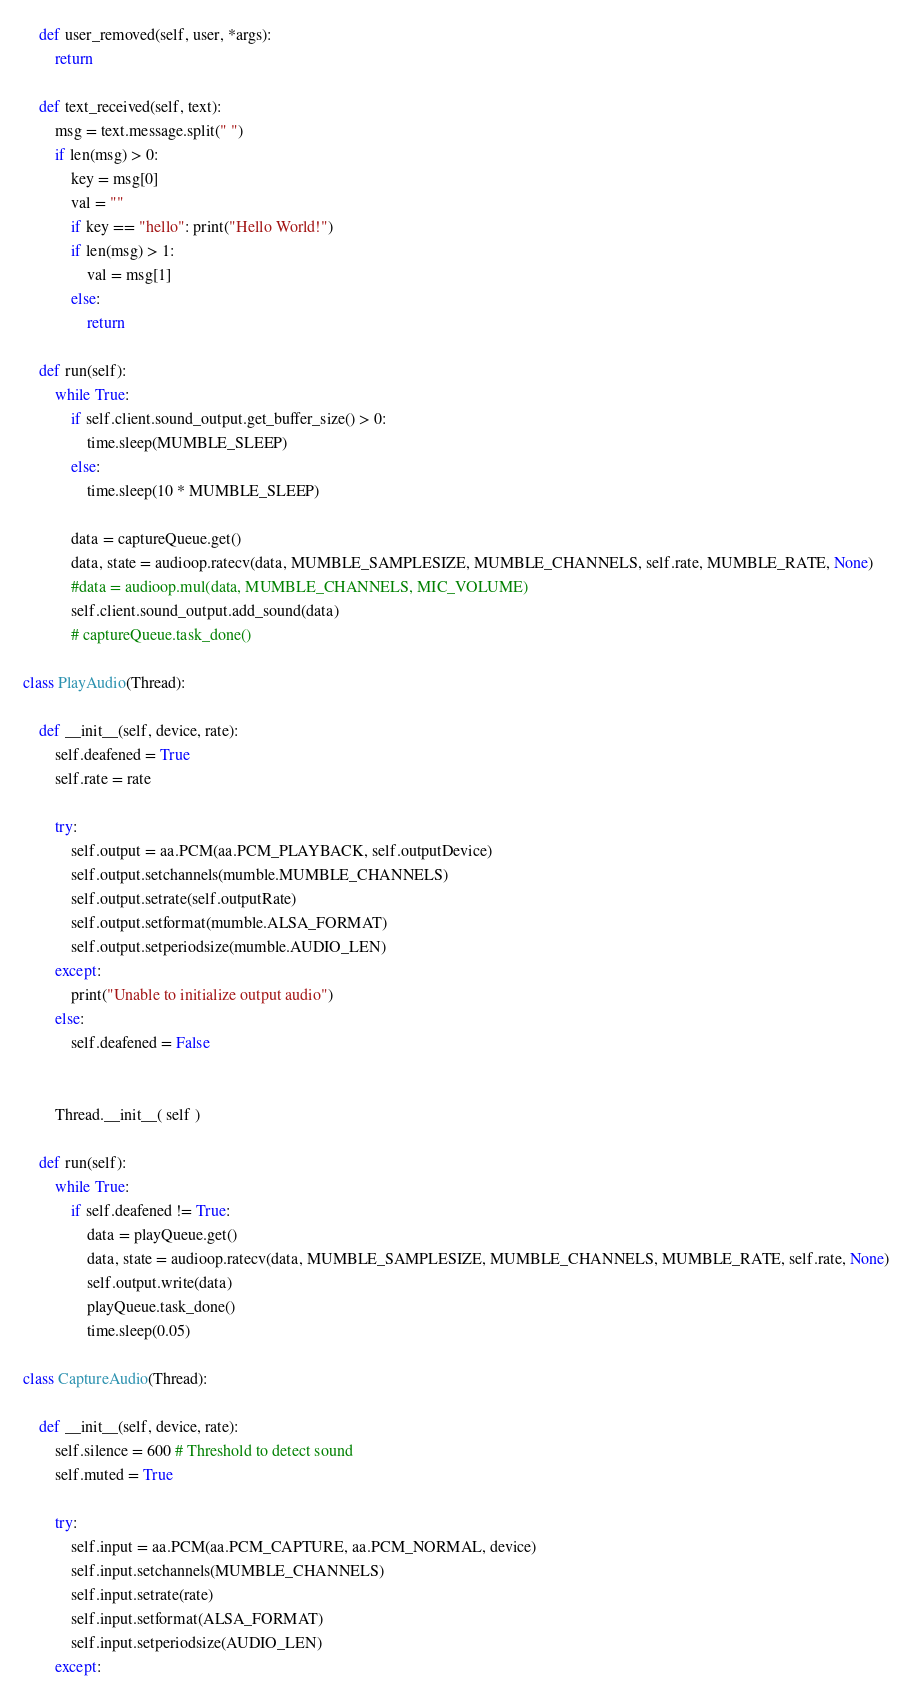Convert code to text. <code><loc_0><loc_0><loc_500><loc_500><_Python_>
    def user_removed(self, user, *args):
        return

    def text_received(self, text):
        msg = text.message.split(" ")
        if len(msg) > 0:
            key = msg[0]
            val = ""
            if key == "hello": print("Hello World!")
            if len(msg) > 1:
                val = msg[1]
            else:
                return

    def run(self):
        while True:
            if self.client.sound_output.get_buffer_size() > 0:
                time.sleep(MUMBLE_SLEEP)
            else:
                time.sleep(10 * MUMBLE_SLEEP)

            data = captureQueue.get()
            data, state = audioop.ratecv(data, MUMBLE_SAMPLESIZE, MUMBLE_CHANNELS, self.rate, MUMBLE_RATE, None)
            #data = audioop.mul(data, MUMBLE_CHANNELS, MIC_VOLUME)
            self.client.sound_output.add_sound(data)
            # captureQueue.task_done()
                
class PlayAudio(Thread):
    
    def __init__(self, device, rate):
        self.deafened = True
        self.rate = rate

        try:
            self.output = aa.PCM(aa.PCM_PLAYBACK, self.outputDevice)
            self.output.setchannels(mumble.MUMBLE_CHANNELS)
            self.output.setrate(self.outputRate)
            self.output.setformat(mumble.ALSA_FORMAT)
            self.output.setperiodsize(mumble.AUDIO_LEN)
        except:
            print("Unable to initialize output audio")
        else:
            self.deafened = False

 
        Thread.__init__( self )

    def run(self):
        while True:
            if self.deafened != True:
                data = playQueue.get()
                data, state = audioop.ratecv(data, MUMBLE_SAMPLESIZE, MUMBLE_CHANNELS, MUMBLE_RATE, self.rate, None)
                self.output.write(data)
                playQueue.task_done()
                time.sleep(0.05)

class CaptureAudio(Thread):
    
    def __init__(self, device, rate):
        self.silence = 600 # Threshold to detect sound
        self.muted = True

        try:
            self.input = aa.PCM(aa.PCM_CAPTURE, aa.PCM_NORMAL, device)
            self.input.setchannels(MUMBLE_CHANNELS)
            self.input.setrate(rate)
            self.input.setformat(ALSA_FORMAT)
            self.input.setperiodsize(AUDIO_LEN)
        except:</code> 